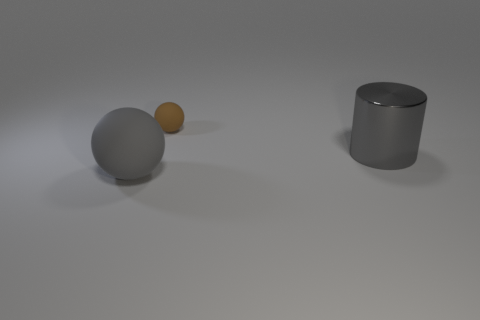Add 3 blocks. How many objects exist? 6 Subtract all cylinders. How many objects are left? 2 Subtract all large blue balls. Subtract all large gray metallic objects. How many objects are left? 2 Add 2 metallic objects. How many metallic objects are left? 3 Add 3 brown objects. How many brown objects exist? 4 Subtract 0 red cylinders. How many objects are left? 3 